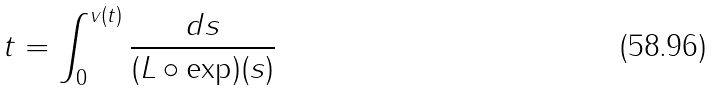<formula> <loc_0><loc_0><loc_500><loc_500>t = \int _ { 0 } ^ { v ( t ) } \frac { d s } { ( L \circ \exp ) ( s ) }</formula> 